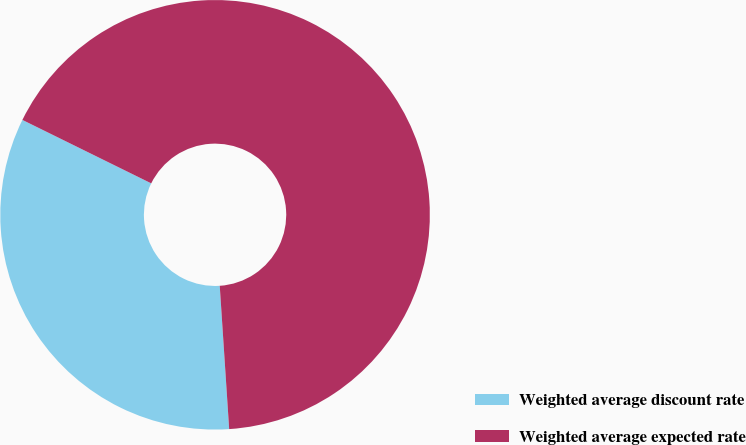Convert chart to OTSL. <chart><loc_0><loc_0><loc_500><loc_500><pie_chart><fcel>Weighted average discount rate<fcel>Weighted average expected rate<nl><fcel>33.33%<fcel>66.67%<nl></chart> 